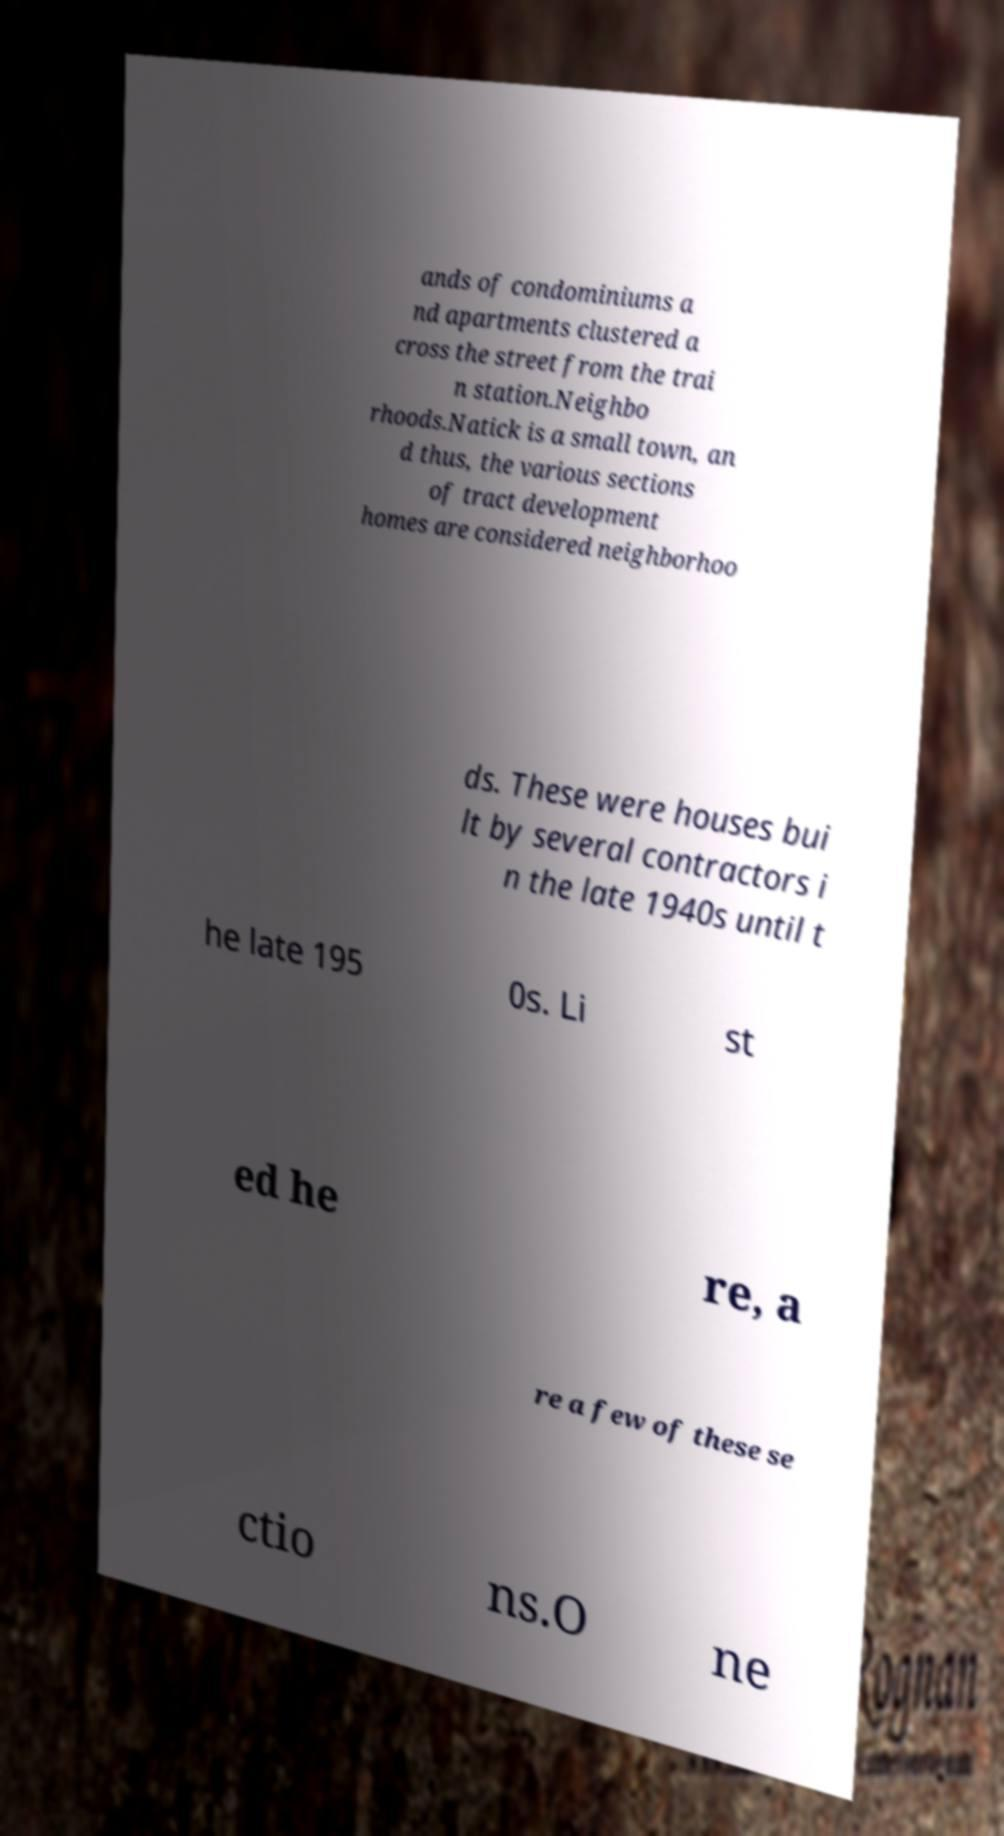Can you read and provide the text displayed in the image?This photo seems to have some interesting text. Can you extract and type it out for me? ands of condominiums a nd apartments clustered a cross the street from the trai n station.Neighbo rhoods.Natick is a small town, an d thus, the various sections of tract development homes are considered neighborhoo ds. These were houses bui lt by several contractors i n the late 1940s until t he late 195 0s. Li st ed he re, a re a few of these se ctio ns.O ne 